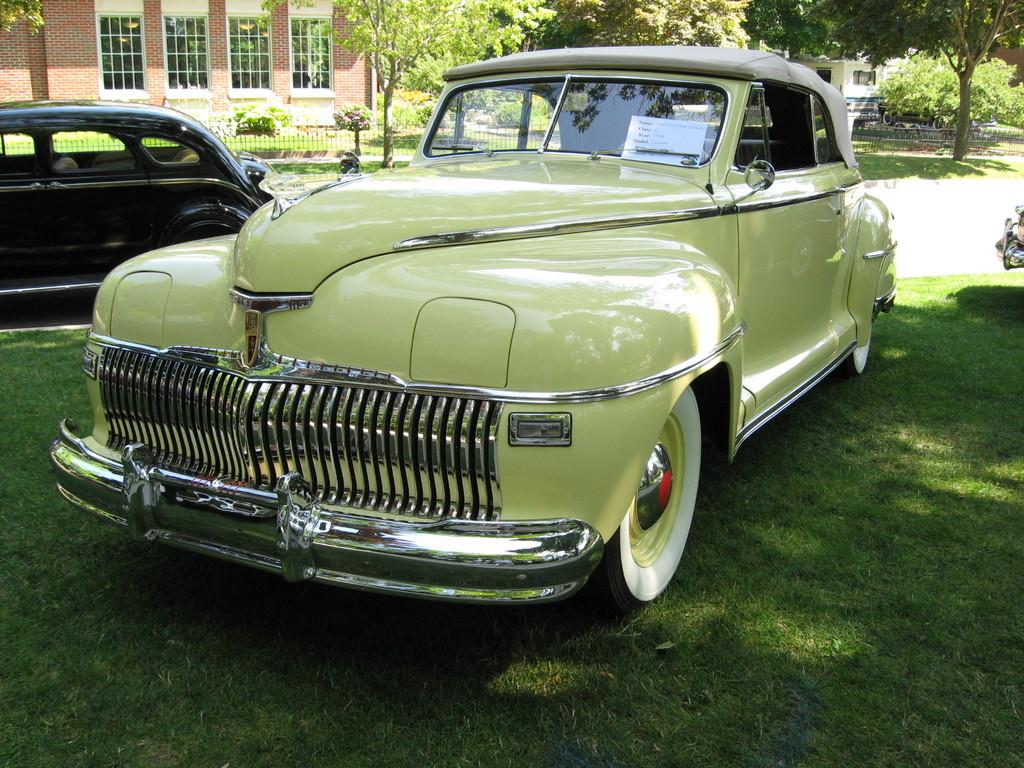What can be seen parked on the ground in the image? There are cars parked on the ground in the image. What type of vegetation is visible in the image? There is grass, a group of trees, and plants visible in the image. What is the purpose of the fence in the image? The fence in the image serves as a boundary or barrier. What type of structure is present with windows in the image? There is a building with windows in the image. How many flowers are on the secretary's desk in the image? There is no secretary or desk present in the image; it features cars, grass, trees, plants, a fence, and a building. What type of wheel is visible on the secretary's chair in the image? There is no secretary, desk, or chair present in the image, so there are no wheels visible. 